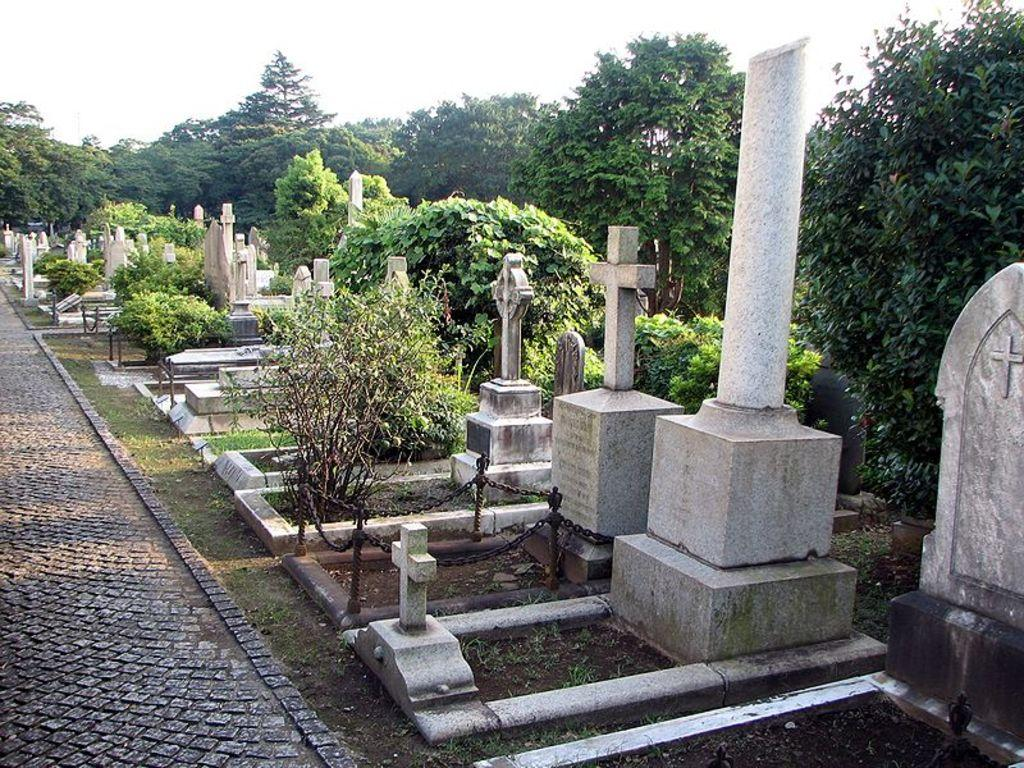What type of tombs are visible in the image? There are many Christian tombs in the image. What can be seen surrounding the tombs? There are trees and plants around the tombs. Is there a specific path visible in the image? Yes, there is a path on the left side of the tombs. What type of juice is being served at the tombs in the image? There is no juice being served in the image; it features Christian tombs surrounded by trees and plants. 